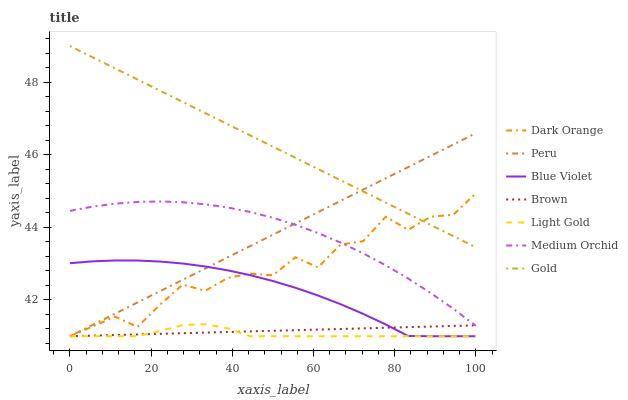Does Light Gold have the minimum area under the curve?
Answer yes or no. Yes. Does Gold have the maximum area under the curve?
Answer yes or no. Yes. Does Brown have the minimum area under the curve?
Answer yes or no. No. Does Brown have the maximum area under the curve?
Answer yes or no. No. Is Brown the smoothest?
Answer yes or no. Yes. Is Dark Orange the roughest?
Answer yes or no. Yes. Is Gold the smoothest?
Answer yes or no. No. Is Gold the roughest?
Answer yes or no. No. Does Dark Orange have the lowest value?
Answer yes or no. Yes. Does Gold have the lowest value?
Answer yes or no. No. Does Gold have the highest value?
Answer yes or no. Yes. Does Brown have the highest value?
Answer yes or no. No. Is Light Gold less than Gold?
Answer yes or no. Yes. Is Gold greater than Light Gold?
Answer yes or no. Yes. Does Blue Violet intersect Light Gold?
Answer yes or no. Yes. Is Blue Violet less than Light Gold?
Answer yes or no. No. Is Blue Violet greater than Light Gold?
Answer yes or no. No. Does Light Gold intersect Gold?
Answer yes or no. No. 